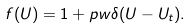Convert formula to latex. <formula><loc_0><loc_0><loc_500><loc_500>f ( U ) = 1 + p w \delta ( U - U _ { t } ) .</formula> 